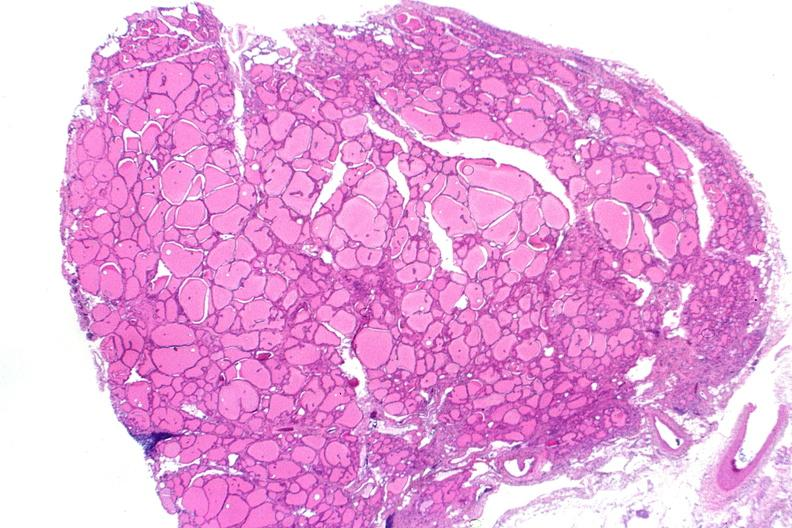what is present?
Answer the question using a single word or phrase. Endocrine 